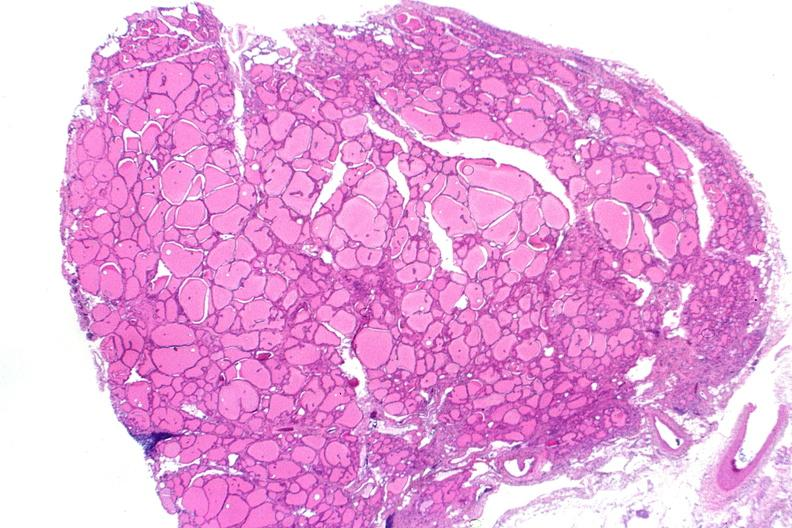what is present?
Answer the question using a single word or phrase. Endocrine 